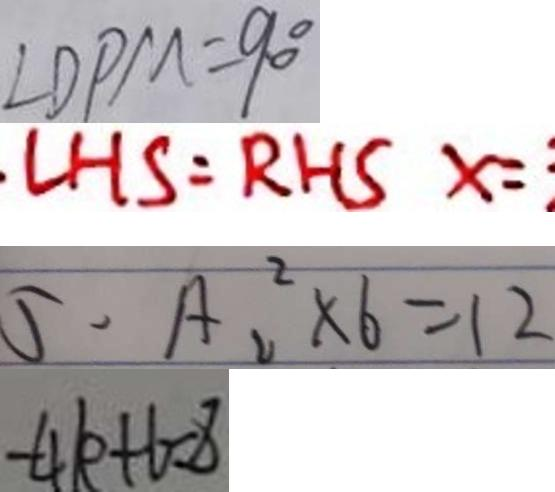Convert formula to latex. <formula><loc_0><loc_0><loc_500><loc_500>\angle D P M = 9 0 ^ { \circ } 
 L H S = R H S x = 
 5 . A _ { 2 } ^ { 2 } \times 6 = 1 2 
 - 4 k + 6 = 8</formula> 